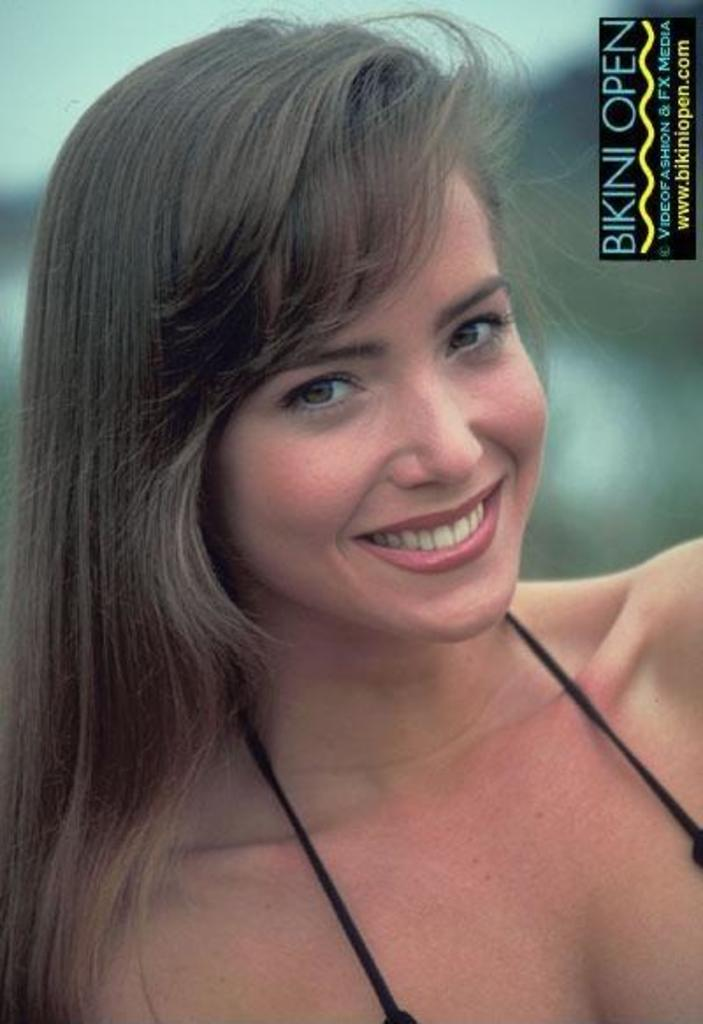Who is present in the image? There is a woman in the image. What is the woman's facial expression? The woman is smiling. What can be seen in the top right corner of the image? There is some text in the top right corner of the image. How would you describe the background of the image? The background of the image is blurry. What type of haircut does the fireman have in the image? There is no fireman present in the image, and therefore no haircut to describe. 